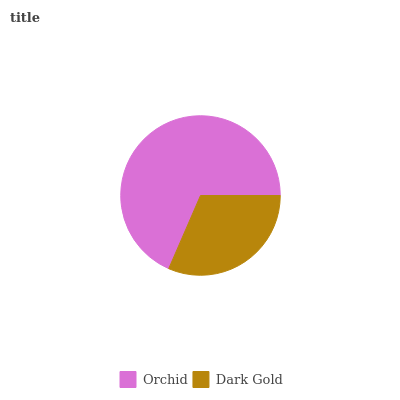Is Dark Gold the minimum?
Answer yes or no. Yes. Is Orchid the maximum?
Answer yes or no. Yes. Is Dark Gold the maximum?
Answer yes or no. No. Is Orchid greater than Dark Gold?
Answer yes or no. Yes. Is Dark Gold less than Orchid?
Answer yes or no. Yes. Is Dark Gold greater than Orchid?
Answer yes or no. No. Is Orchid less than Dark Gold?
Answer yes or no. No. Is Orchid the high median?
Answer yes or no. Yes. Is Dark Gold the low median?
Answer yes or no. Yes. Is Dark Gold the high median?
Answer yes or no. No. Is Orchid the low median?
Answer yes or no. No. 